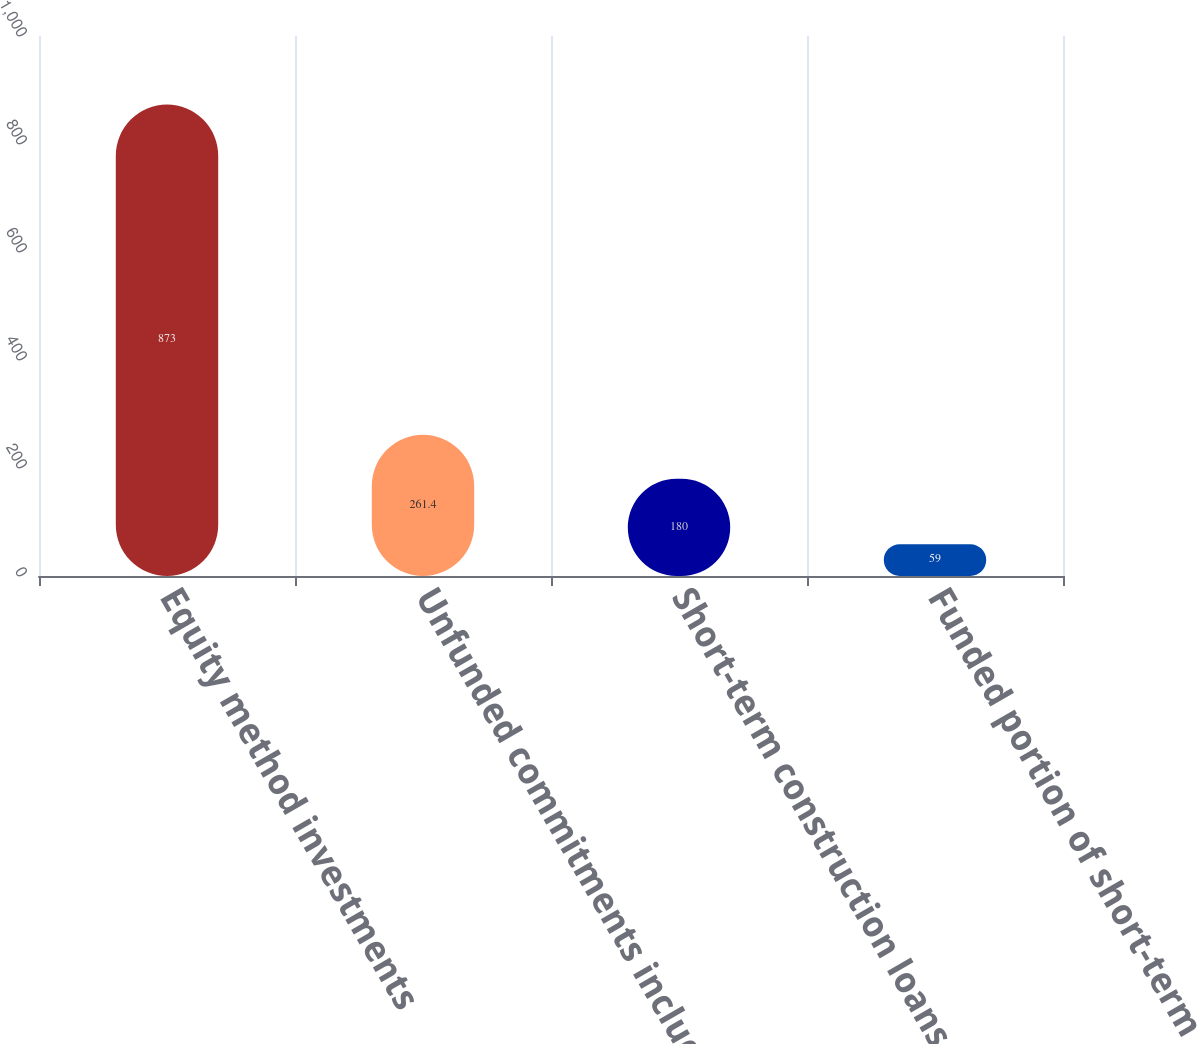<chart> <loc_0><loc_0><loc_500><loc_500><bar_chart><fcel>Equity method investments<fcel>Unfunded commitments included<fcel>Short-term construction loans<fcel>Funded portion of short-term<nl><fcel>873<fcel>261.4<fcel>180<fcel>59<nl></chart> 